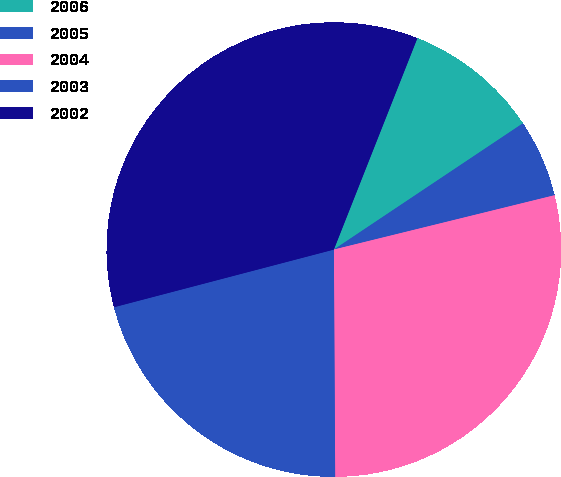Convert chart. <chart><loc_0><loc_0><loc_500><loc_500><pie_chart><fcel>2006<fcel>2005<fcel>2004<fcel>2003<fcel>2002<nl><fcel>9.64%<fcel>5.53%<fcel>28.75%<fcel>21.01%<fcel>35.07%<nl></chart> 